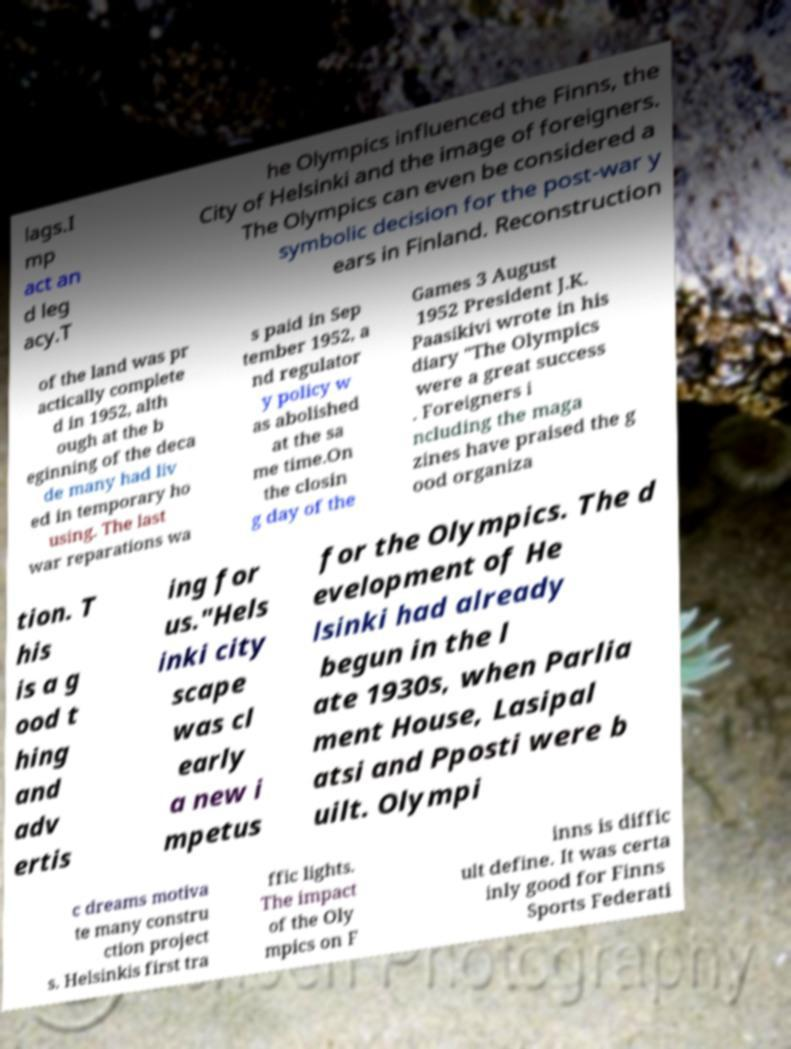Could you assist in decoding the text presented in this image and type it out clearly? lags.I mp act an d leg acy.T he Olympics influenced the Finns, the City of Helsinki and the image of foreigners. The Olympics can even be considered a symbolic decision for the post-war y ears in Finland. Reconstruction of the land was pr actically complete d in 1952, alth ough at the b eginning of the deca de many had liv ed in temporary ho using. The last war reparations wa s paid in Sep tember 1952, a nd regulator y policy w as abolished at the sa me time.On the closin g day of the Games 3 August 1952 President J.K. Paasikivi wrote in his diary "The Olympics were a great success . Foreigners i ncluding the maga zines have praised the g ood organiza tion. T his is a g ood t hing and adv ertis ing for us."Hels inki city scape was cl early a new i mpetus for the Olympics. The d evelopment of He lsinki had already begun in the l ate 1930s, when Parlia ment House, Lasipal atsi and Pposti were b uilt. Olympi c dreams motiva te many constru ction project s. Helsinkis first tra ffic lights. The impact of the Oly mpics on F inns is diffic ult define. It was certa inly good for Finns Sports Federati 